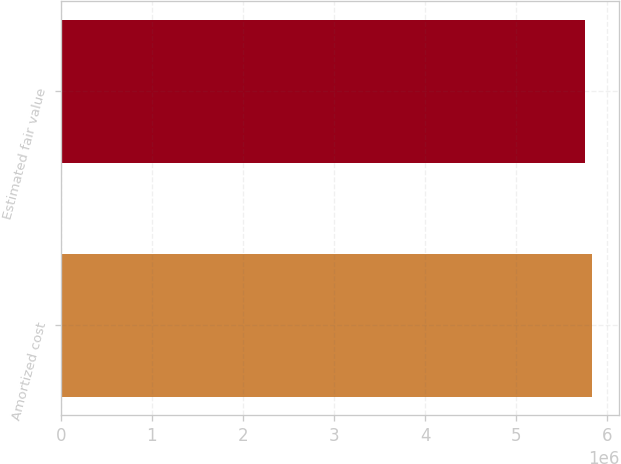Convert chart to OTSL. <chart><loc_0><loc_0><loc_500><loc_500><bar_chart><fcel>Amortized cost<fcel>Estimated fair value<nl><fcel>5.83734e+06<fcel>5.75382e+06<nl></chart> 